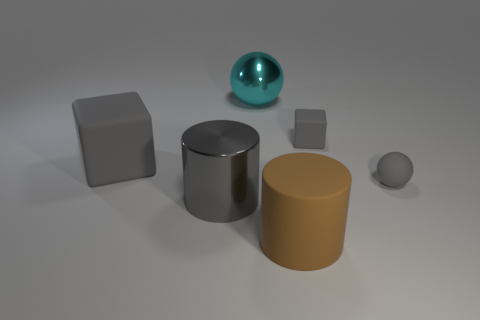Add 2 tiny red cubes. How many objects exist? 8 Subtract all cyan spheres. How many spheres are left? 1 Subtract 1 cubes. How many cubes are left? 1 Subtract all big brown matte cylinders. Subtract all brown rubber things. How many objects are left? 4 Add 1 small rubber cubes. How many small rubber cubes are left? 2 Add 6 large brown things. How many large brown things exist? 7 Subtract 0 green spheres. How many objects are left? 6 Subtract all cubes. How many objects are left? 4 Subtract all yellow blocks. Subtract all brown balls. How many blocks are left? 2 Subtract all purple cylinders. How many gray spheres are left? 1 